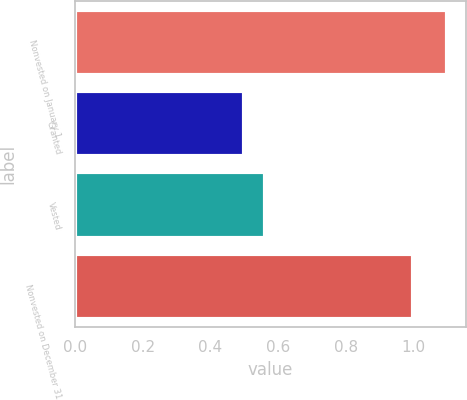Convert chart to OTSL. <chart><loc_0><loc_0><loc_500><loc_500><bar_chart><fcel>Nonvested on January 1<fcel>Granted<fcel>Vested<fcel>Nonvested on December 31<nl><fcel>1.1<fcel>0.5<fcel>0.56<fcel>1<nl></chart> 